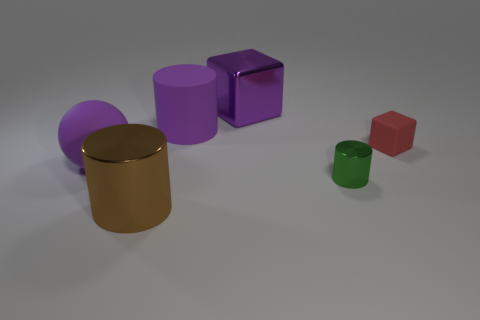Add 1 rubber cylinders. How many objects exist? 7 Subtract all cubes. How many objects are left? 4 Subtract all large cyan metallic balls. Subtract all metallic cylinders. How many objects are left? 4 Add 6 purple balls. How many purple balls are left? 7 Add 5 tiny green matte spheres. How many tiny green matte spheres exist? 5 Subtract 1 purple cylinders. How many objects are left? 5 